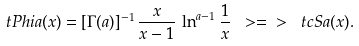Convert formula to latex. <formula><loc_0><loc_0><loc_500><loc_500>\ t P h i { a } ( x ) = [ \Gamma ( a ) ] ^ { - 1 } \, \frac { x } { x - 1 } \, \ln ^ { a - 1 } \frac { 1 } { x } \ > = \ > \ t c S { a } ( x ) .</formula> 